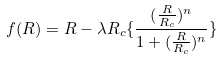Convert formula to latex. <formula><loc_0><loc_0><loc_500><loc_500>f ( R ) = R - \lambda R _ { c } \{ \frac { ( \frac { R } { R _ { c } } ) ^ { n } } { 1 + ( \frac { R } { R _ { c } } ) ^ { n } } \}</formula> 